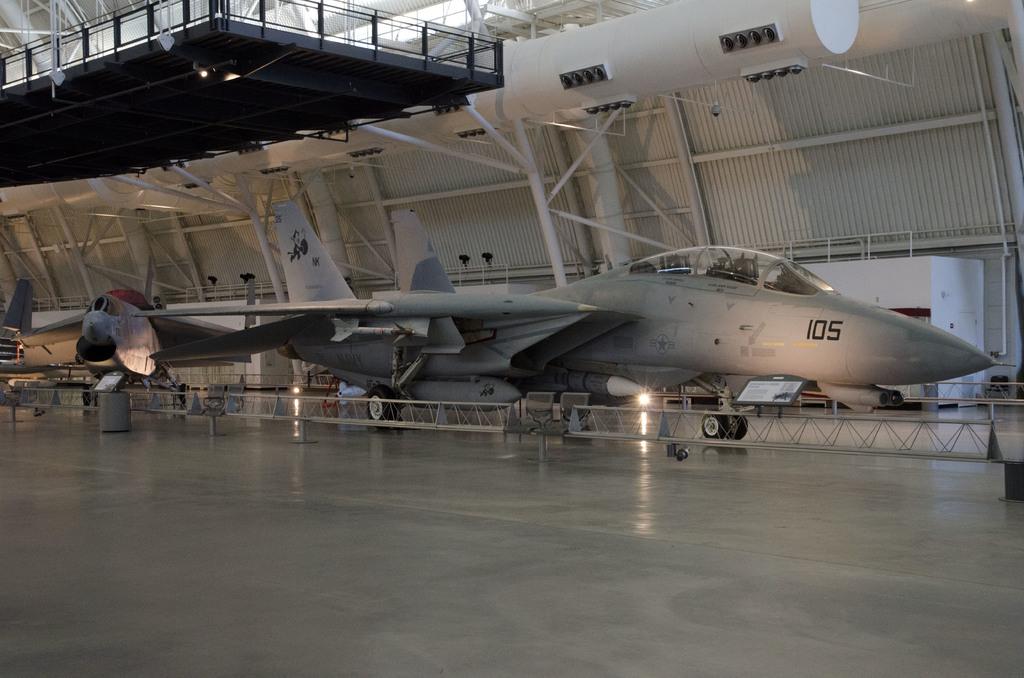What plane number is this?
Offer a very short reply. 105. 